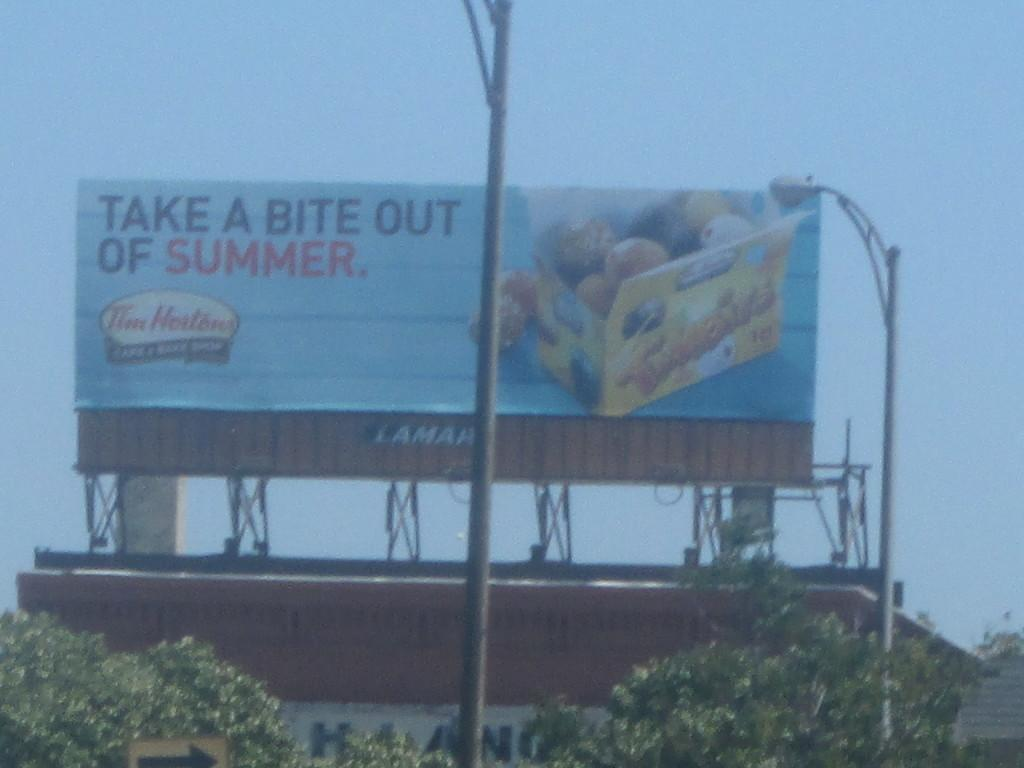<image>
Give a short and clear explanation of the subsequent image. A big billboard for tim hortons that says to take a bite out of summer. 